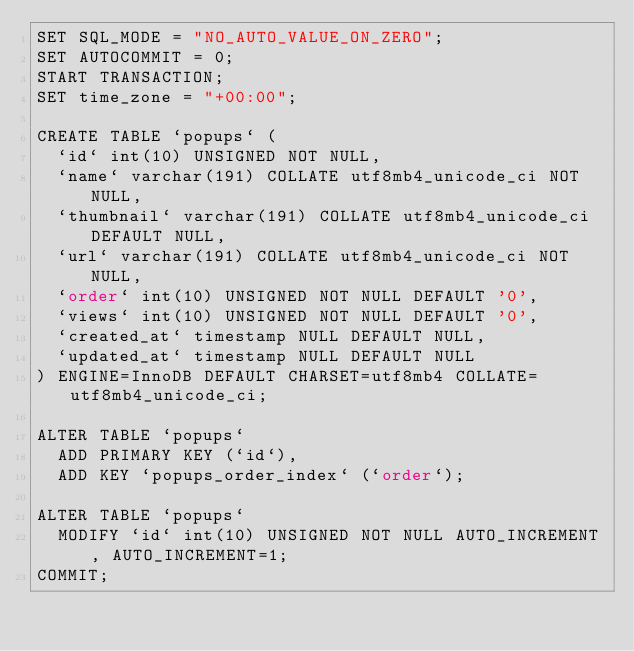Convert code to text. <code><loc_0><loc_0><loc_500><loc_500><_SQL_>SET SQL_MODE = "NO_AUTO_VALUE_ON_ZERO";
SET AUTOCOMMIT = 0;
START TRANSACTION;
SET time_zone = "+00:00";

CREATE TABLE `popups` (
  `id` int(10) UNSIGNED NOT NULL,
  `name` varchar(191) COLLATE utf8mb4_unicode_ci NOT NULL,
  `thumbnail` varchar(191) COLLATE utf8mb4_unicode_ci DEFAULT NULL,
  `url` varchar(191) COLLATE utf8mb4_unicode_ci NOT NULL,
  `order` int(10) UNSIGNED NOT NULL DEFAULT '0',
  `views` int(10) UNSIGNED NOT NULL DEFAULT '0',
  `created_at` timestamp NULL DEFAULT NULL,
  `updated_at` timestamp NULL DEFAULT NULL
) ENGINE=InnoDB DEFAULT CHARSET=utf8mb4 COLLATE=utf8mb4_unicode_ci;

ALTER TABLE `popups`
  ADD PRIMARY KEY (`id`),
  ADD KEY `popups_order_index` (`order`);

ALTER TABLE `popups`
  MODIFY `id` int(10) UNSIGNED NOT NULL AUTO_INCREMENT, AUTO_INCREMENT=1;
COMMIT;
</code> 